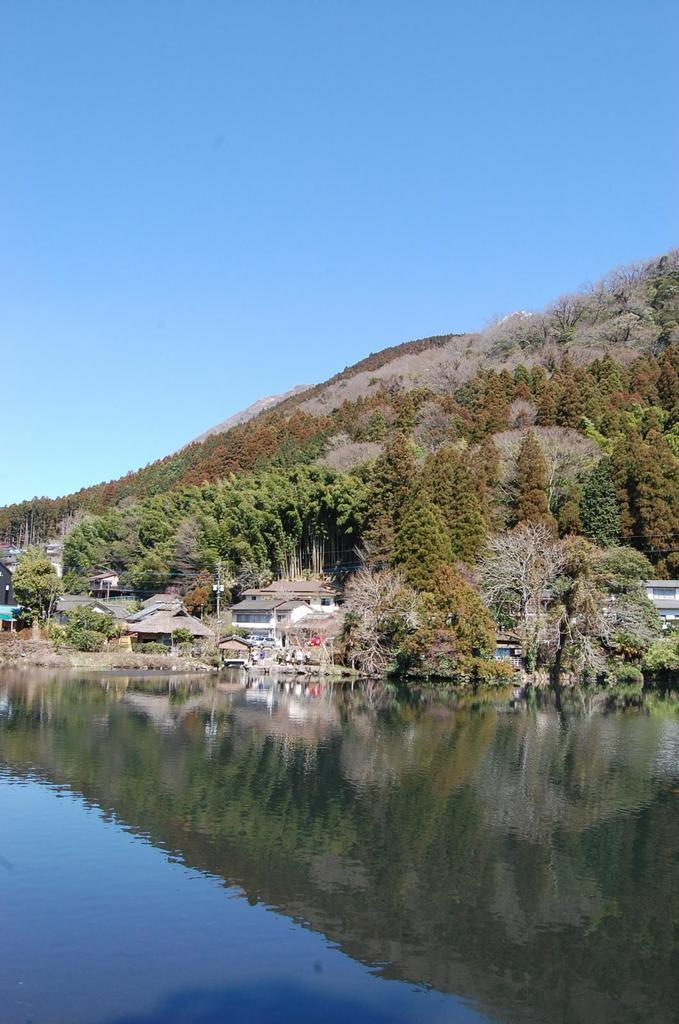What is visible in the image? Water, buildings, trees, a mountain, and the sky are visible in the image. Can you describe the landscape in the image? The image features a combination of natural elements like water, trees, and a mountain, as well as man-made structures such as buildings. What is the background of the image? The sky is visible in the background of the image. What type of corn is being juiced in the image? There is no corn or juice present in the image. 